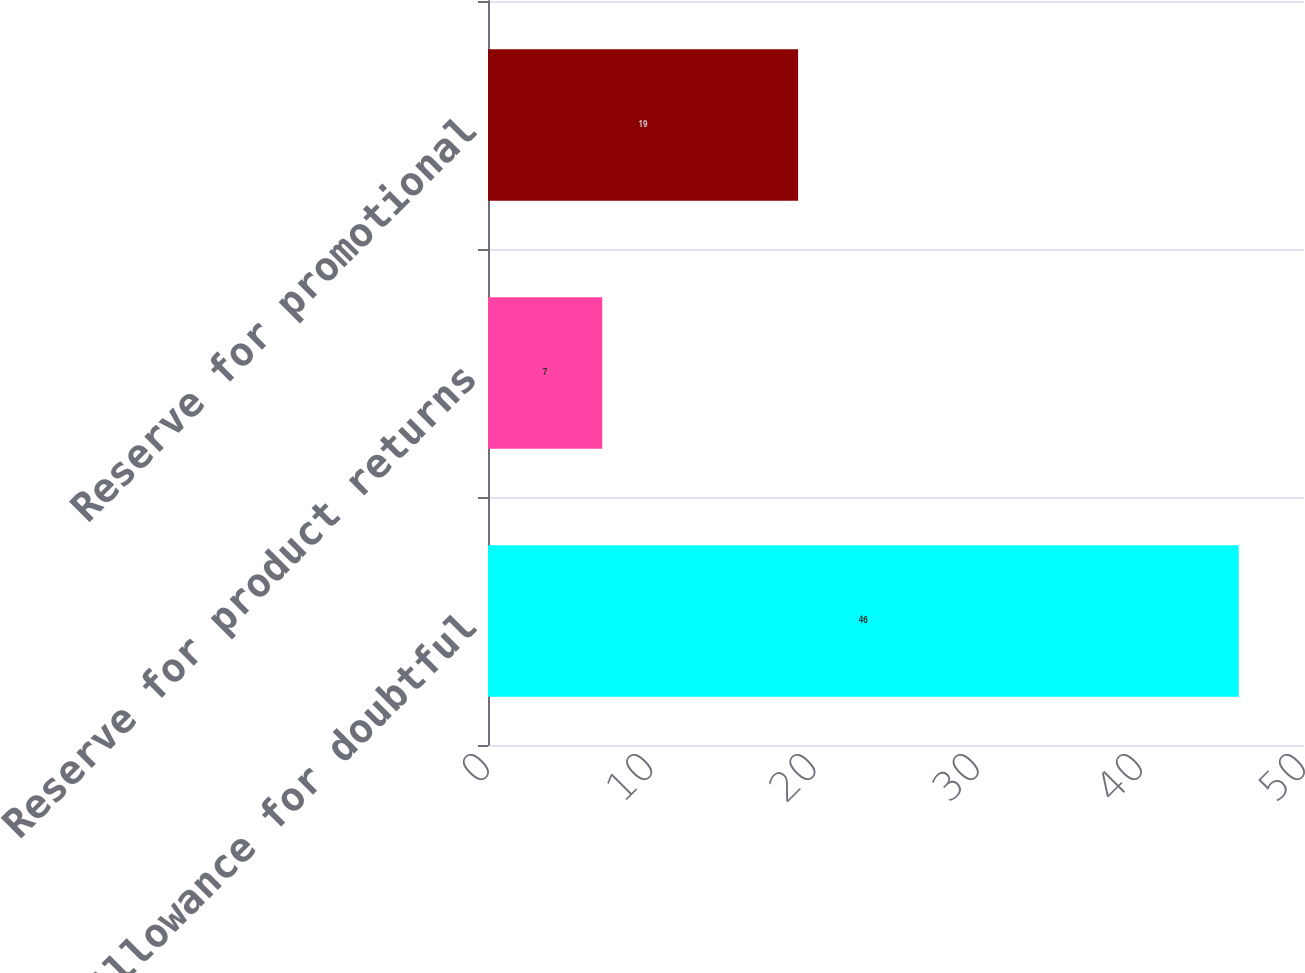Convert chart to OTSL. <chart><loc_0><loc_0><loc_500><loc_500><bar_chart><fcel>Allowance for doubtful<fcel>Reserve for product returns<fcel>Reserve for promotional<nl><fcel>46<fcel>7<fcel>19<nl></chart> 